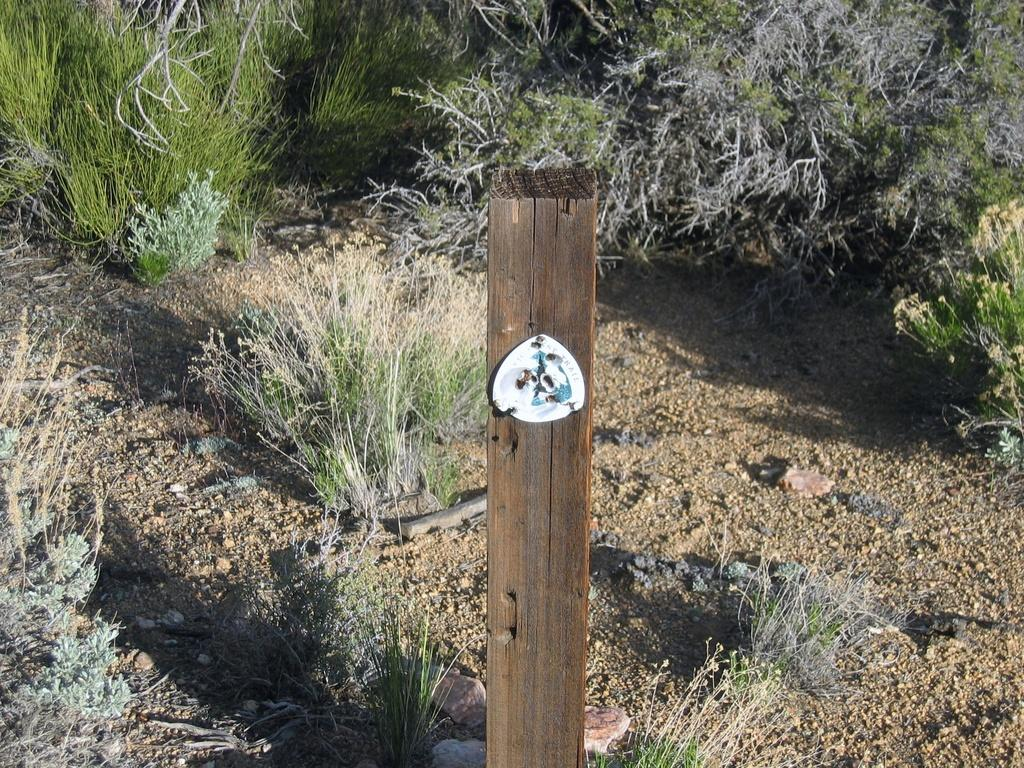What is the main object in the image? There is a wooden pole in the image. What type of vegetation is present behind the pole? Grass and plants are visible behind the pole. What type of terrain is shown in the image? There is land in the image. What other objects can be seen in the image? There are stones visible in the image. How many cents can be seen on the wooden pole in the image? There are no cents present on the wooden pole in the image. What type of dog is sitting next to the wooden pole in the image? There is no dog present in the image. 